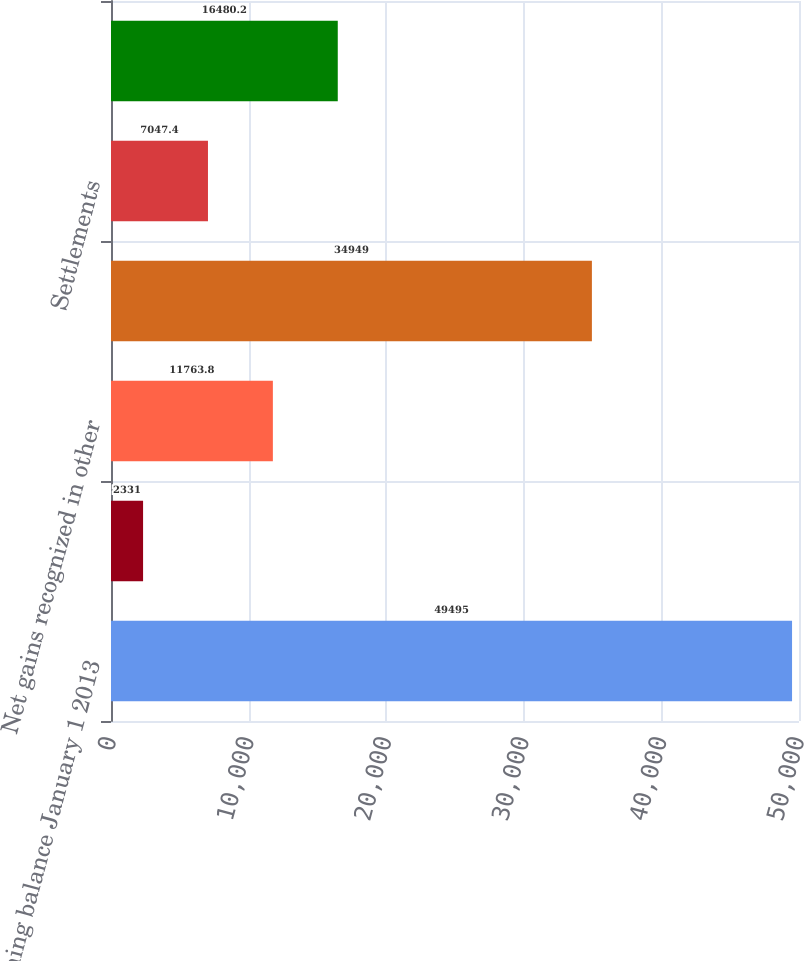Convert chart to OTSL. <chart><loc_0><loc_0><loc_500><loc_500><bar_chart><fcel>Opening balance January 1 2013<fcel>Losses recognized in earnings<fcel>Net gains recognized in other<fcel>Sales<fcel>Settlements<fcel>Closing balance December 31<nl><fcel>49495<fcel>2331<fcel>11763.8<fcel>34949<fcel>7047.4<fcel>16480.2<nl></chart> 